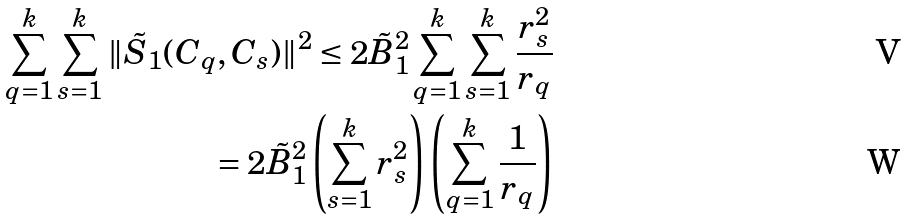<formula> <loc_0><loc_0><loc_500><loc_500>\sum _ { q = 1 } ^ { k } \sum _ { s = 1 } ^ { k } \| \tilde { S } _ { 1 } ( C _ { q } , C _ { s } ) \| ^ { 2 } \leq 2 \tilde { B } _ { 1 } ^ { 2 } \sum _ { q = 1 } ^ { k } \sum _ { s = 1 } ^ { k } \frac { r _ { s } ^ { 2 } } { r _ { q } } \\ = 2 \tilde { B } _ { 1 } ^ { 2 } \left ( \sum _ { s = 1 } ^ { k } r _ { s } ^ { 2 } \right ) \left ( \sum _ { q = 1 } ^ { k } \frac { 1 } { r _ { q } } \right )</formula> 